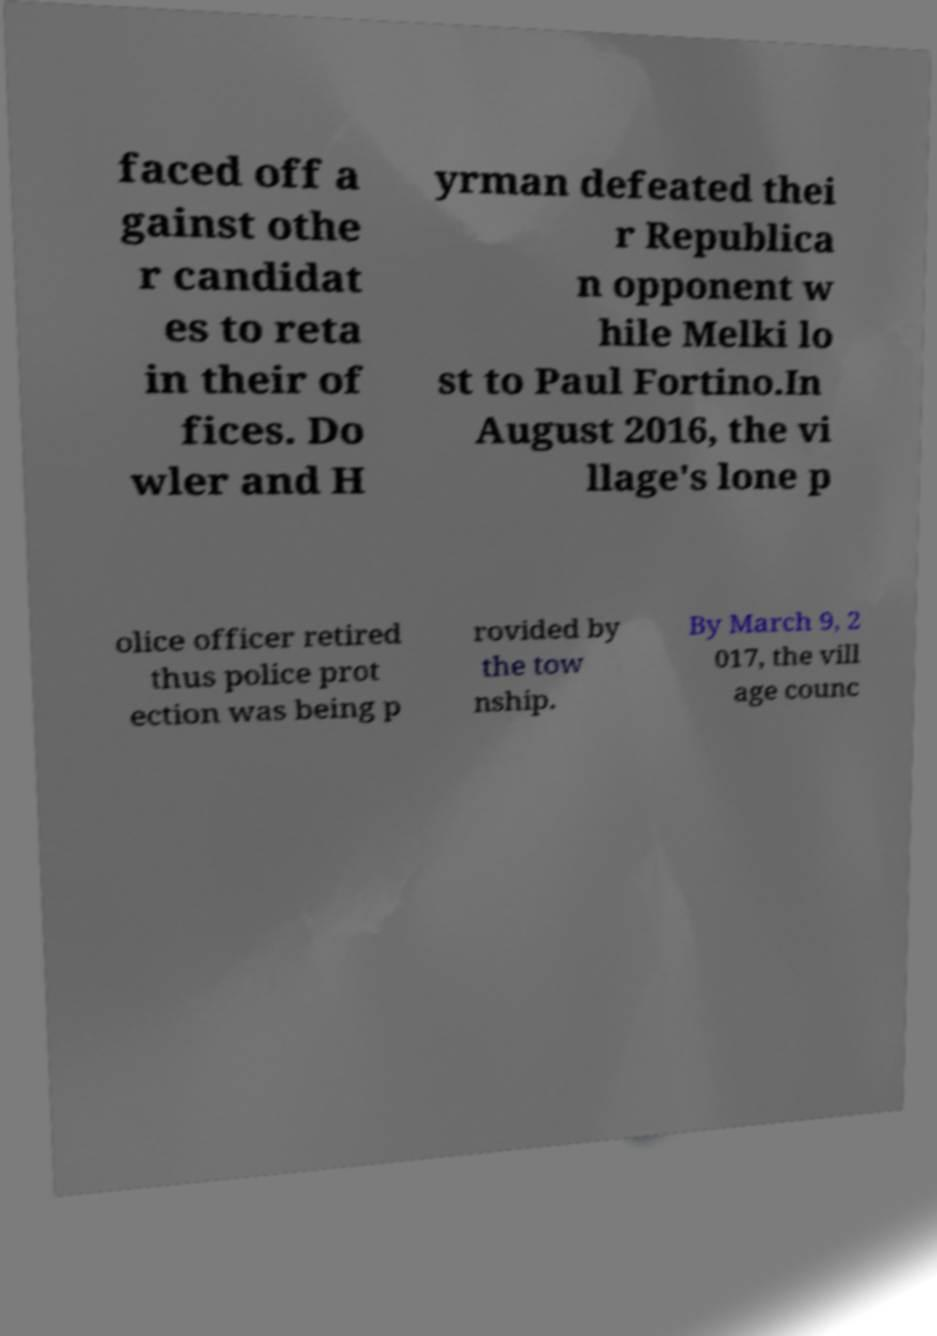Can you accurately transcribe the text from the provided image for me? faced off a gainst othe r candidat es to reta in their of fices. Do wler and H yrman defeated thei r Republica n opponent w hile Melki lo st to Paul Fortino.In August 2016, the vi llage's lone p olice officer retired thus police prot ection was being p rovided by the tow nship. By March 9, 2 017, the vill age counc 